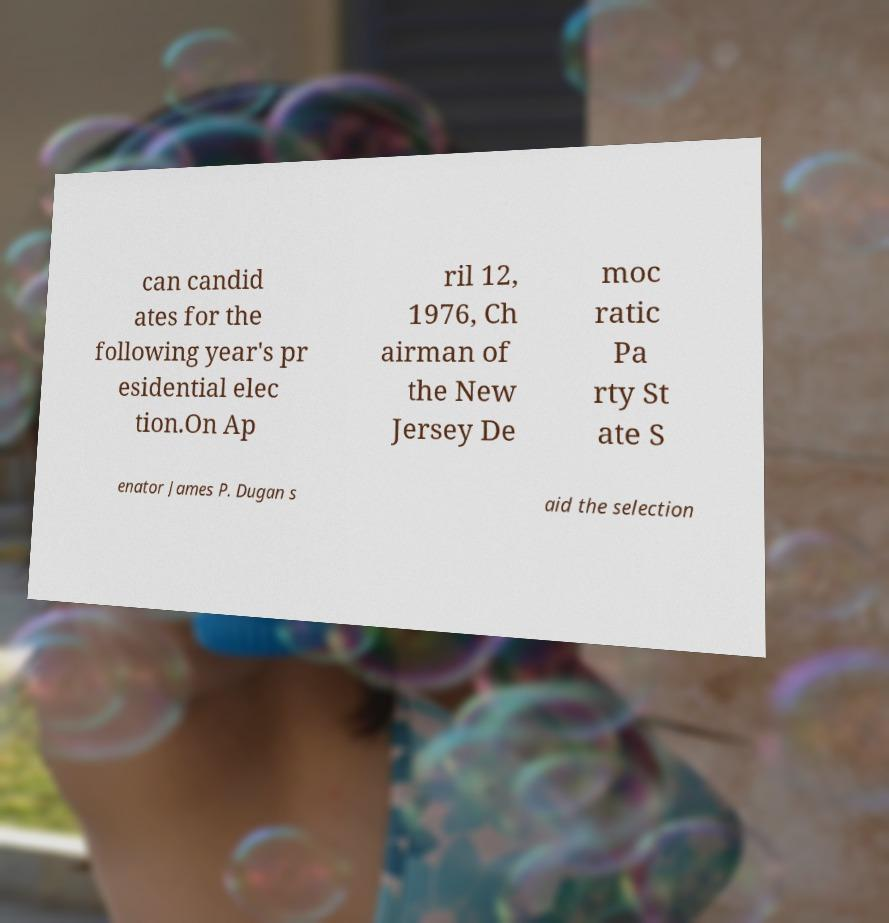Can you accurately transcribe the text from the provided image for me? can candid ates for the following year's pr esidential elec tion.On Ap ril 12, 1976, Ch airman of the New Jersey De moc ratic Pa rty St ate S enator James P. Dugan s aid the selection 